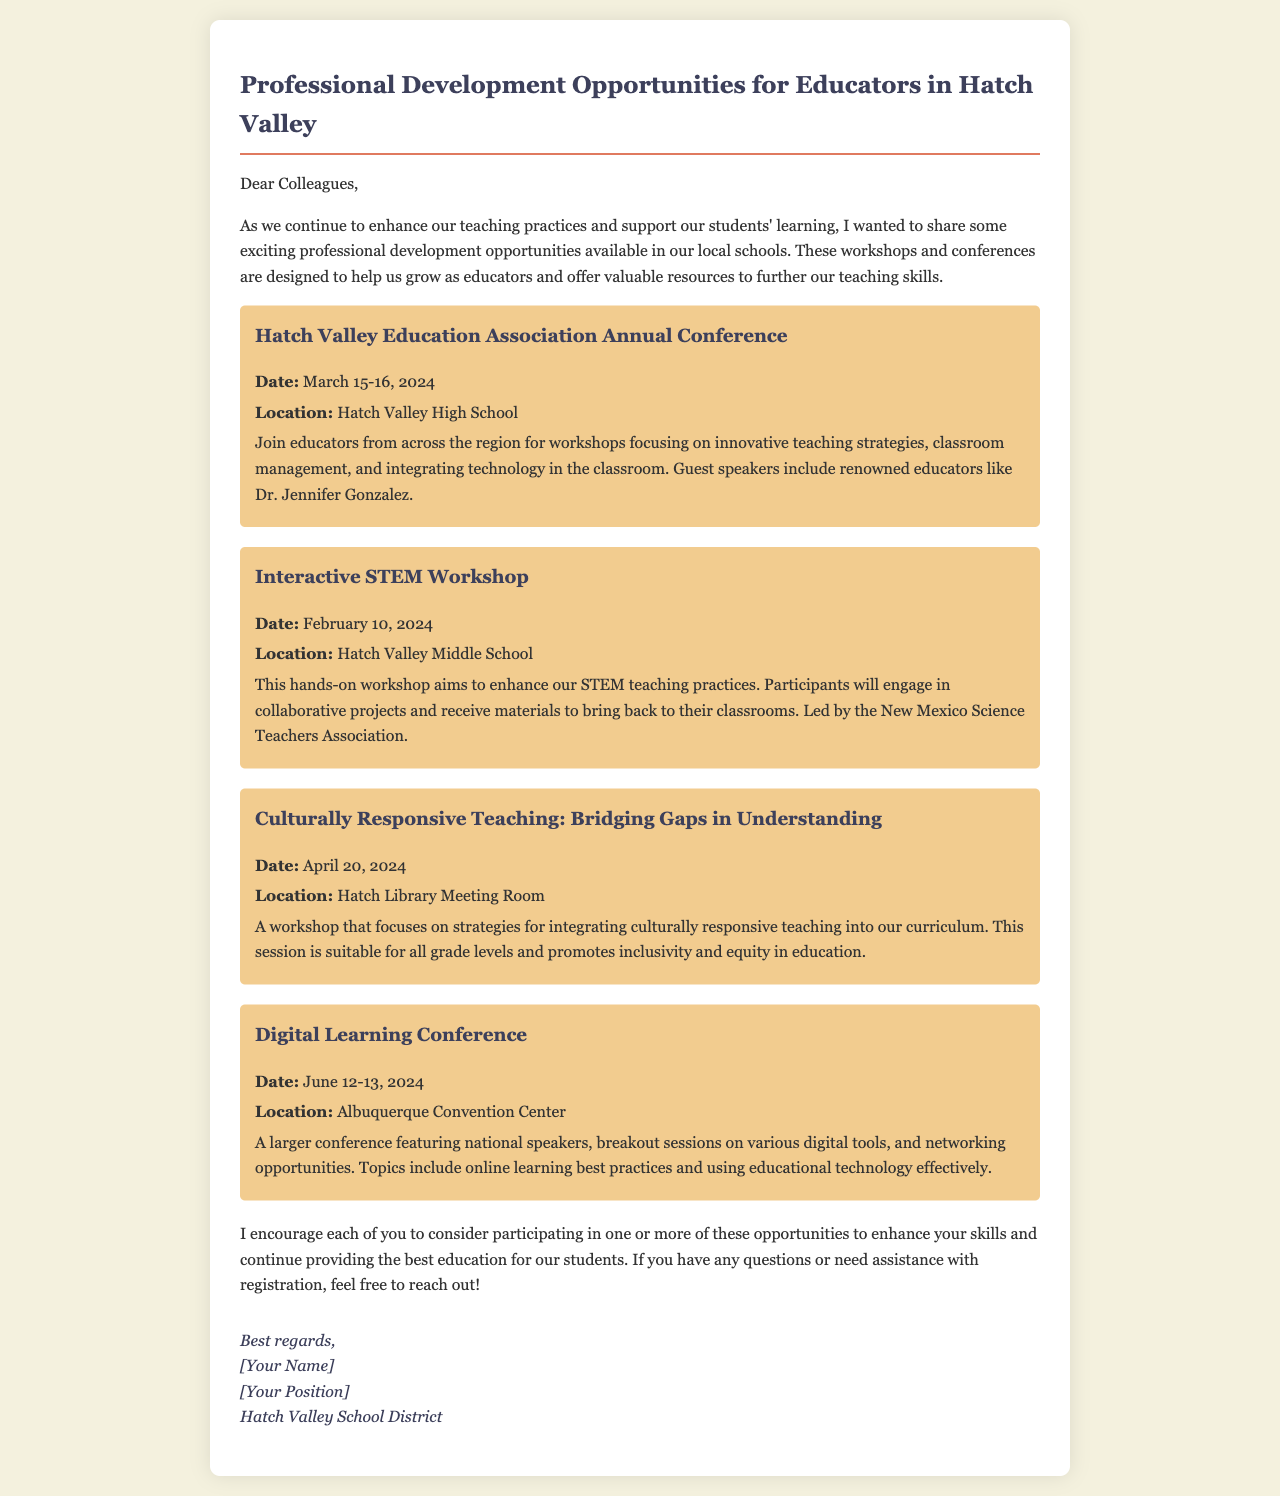What is the date of the Hatch Valley Education Association Annual Conference? The date is mentioned clearly in the document as March 15-16, 2024.
Answer: March 15-16, 2024 Where will the Interactive STEM Workshop take place? The document specifies the location for the workshop as Hatch Valley Middle School.
Answer: Hatch Valley Middle School Who is one of the guest speakers at the Hatch Valley Education Association Annual Conference? The document lists Dr. Jennifer Gonzalez as a renowned educator and guest speaker.
Answer: Dr. Jennifer Gonzalez What is the focus of the workshop titled "Culturally Responsive Teaching: Bridging Gaps in Understanding"? The focus is on integrating culturally responsive teaching into the curriculum as stated in the document.
Answer: Culturally responsive teaching When is the Digital Learning Conference scheduled? The document mentions the dates for the conference as June 12-13, 2024.
Answer: June 12-13, 2024 What organization is leading the Interactive STEM Workshop? The document identifies the New Mexico Science Teachers Association as the leading organization.
Answer: New Mexico Science Teachers Association What type of workshop is scheduled for April 20, 2024? The document classifies it as a workshop focusing on culturally responsive teaching strategies.
Answer: Workshop on culturally responsive teaching How many professional development opportunities are listed in the document? The document lists a total of four different professional development opportunities.
Answer: Four 